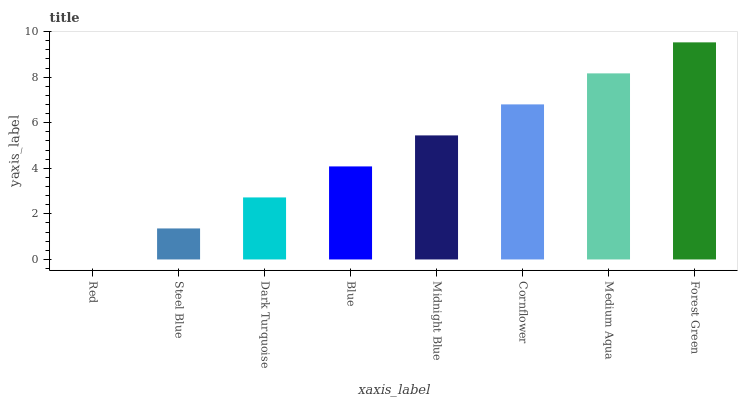Is Red the minimum?
Answer yes or no. Yes. Is Forest Green the maximum?
Answer yes or no. Yes. Is Steel Blue the minimum?
Answer yes or no. No. Is Steel Blue the maximum?
Answer yes or no. No. Is Steel Blue greater than Red?
Answer yes or no. Yes. Is Red less than Steel Blue?
Answer yes or no. Yes. Is Red greater than Steel Blue?
Answer yes or no. No. Is Steel Blue less than Red?
Answer yes or no. No. Is Midnight Blue the high median?
Answer yes or no. Yes. Is Blue the low median?
Answer yes or no. Yes. Is Medium Aqua the high median?
Answer yes or no. No. Is Dark Turquoise the low median?
Answer yes or no. No. 